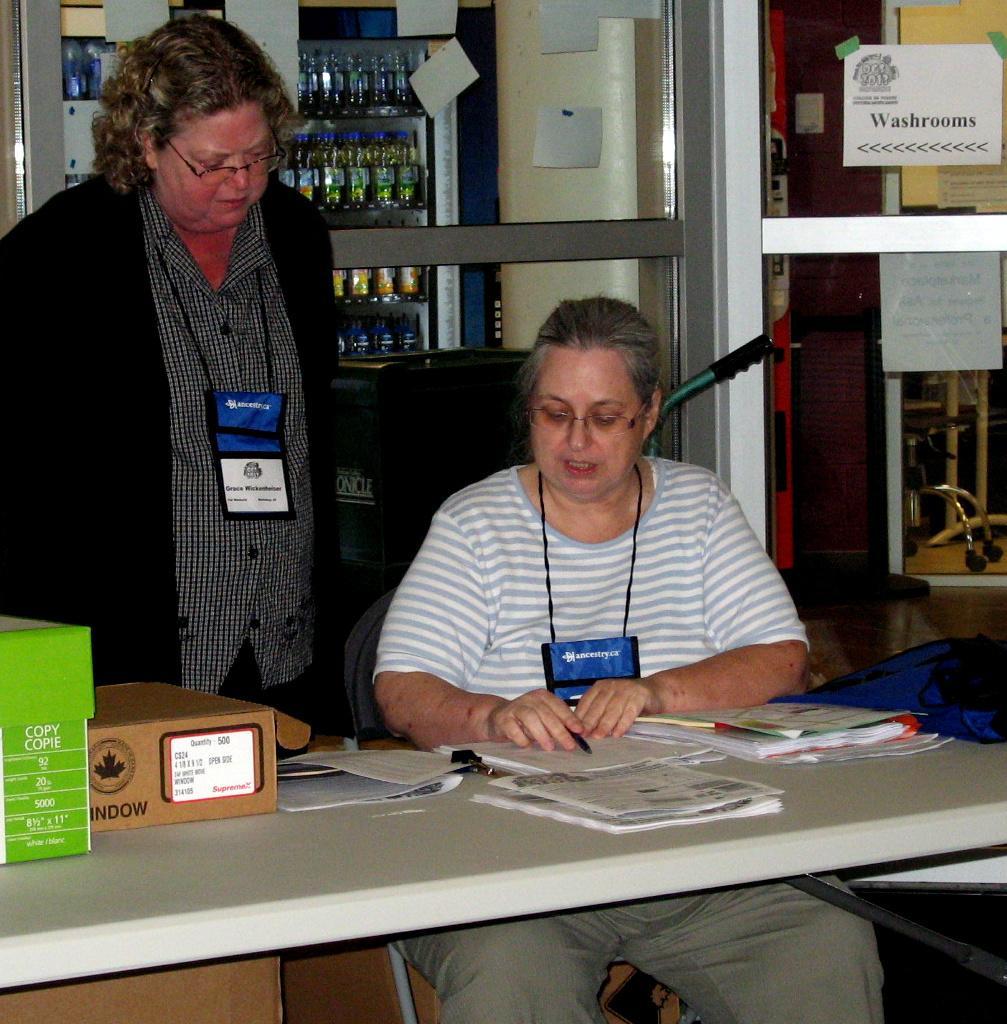Could you give a brief overview of what you see in this image? This image consists of table, two persons and refrigerator, which consists of so many cool drinks in it and chairs. The table has boxes books papers pen on it. Two people they are standing near the table. They are wearing ID cards. One person is sitting in the chair near the table, she is a woman. Beside her there is a door on the right side. 